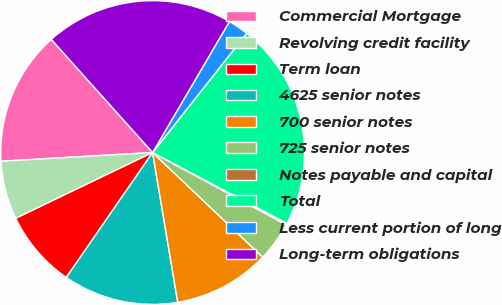Convert chart. <chart><loc_0><loc_0><loc_500><loc_500><pie_chart><fcel>Commercial Mortgage<fcel>Revolving credit facility<fcel>Term loan<fcel>4625 senior notes<fcel>700 senior notes<fcel>725 senior notes<fcel>Notes payable and capital<fcel>Total<fcel>Less current portion of long<fcel>Long-term obligations<nl><fcel>14.29%<fcel>6.22%<fcel>8.24%<fcel>12.27%<fcel>10.26%<fcel>4.2%<fcel>0.17%<fcel>22.09%<fcel>2.19%<fcel>20.07%<nl></chart> 